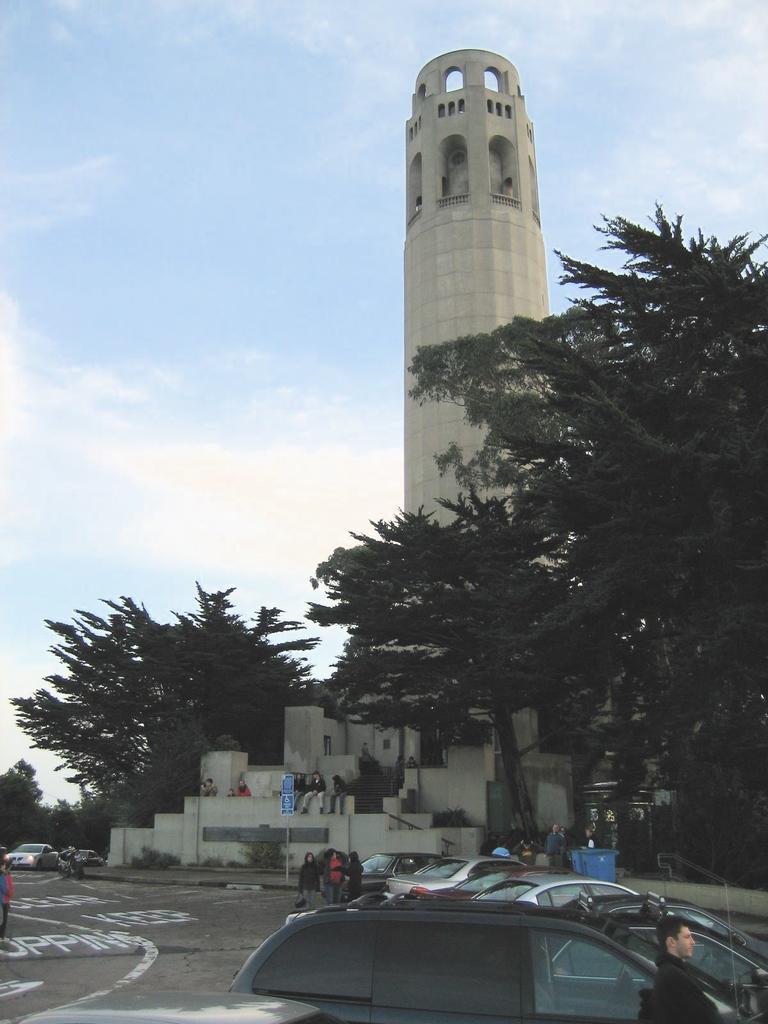Describe this image in one or two sentences. In this picture we can see cars and some persons on the road, trees, building and in the background we can see the sky with clouds. 